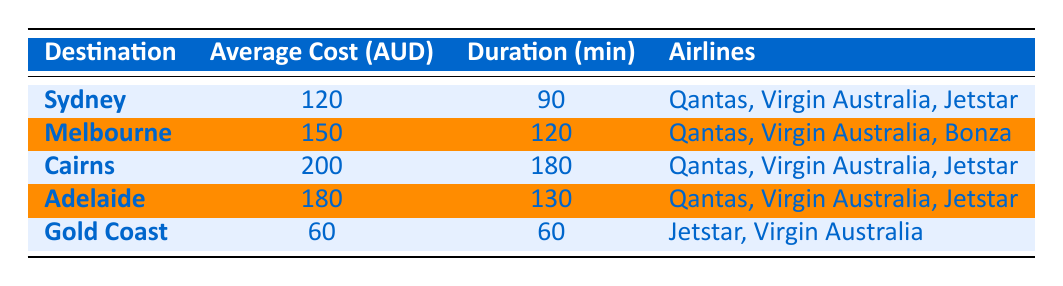What is the average travel cost to Sydney? The table lists the average travel cost to Sydney as 120 AUD.
Answer: 120 AUD Which destination has the lowest average travel cost? Looking at the "Average Cost (AUD)" column, Gold Coast has the lowest cost of 60 AUD.
Answer: Gold Coast How much longer does it take to fly to Cairns compared to Gold Coast? The flight duration to Cairns is 180 minutes and to Gold Coast is 60 minutes. The difference is 180 - 60 = 120 minutes.
Answer: 120 minutes Are there any airlines that fly to both Sydney and Cairns? The table shows that Qantas and Virgin Australia are listed as airlines for both Sydney and Cairns.
Answer: Yes What is the total average cost of flights to all destinations listed? Adding the average costs: 120 (Sydney) + 150 (Melbourne) + 200 (Cairns) + 180 (Adelaide) + 60 (Gold Coast) gives a total of 810 AUD for all destinations. The total is 810 AUD.
Answer: 810 AUD Which destination takes longer to reach, Adelaide or Melbourne? The flight duration to Adelaide is 130 minutes while to Melbourne it's 120 minutes, so Adelaide takes longer by 10 minutes.
Answer: Adelaide How many different airlines serve the destination Melbourne? The table states that there are three airlines serving Melbourne: Qantas, Virgin Australia, and Bonza.
Answer: 3 airlines Is it true that all destinations are served by Qantas? The table confirms that Qantas serves Sydney, Melbourne, Cairns, and Adelaide, but not Gold Coast, which means it's not true.
Answer: No What is the average flight duration to all listed destinations? The average flight duration is calculated by summing the durations (90 + 120 + 180 + 130 + 60) = 680 minutes and dividing by the number of destinations (5). The average is 680 / 5 = 136 minutes.
Answer: 136 minutes 